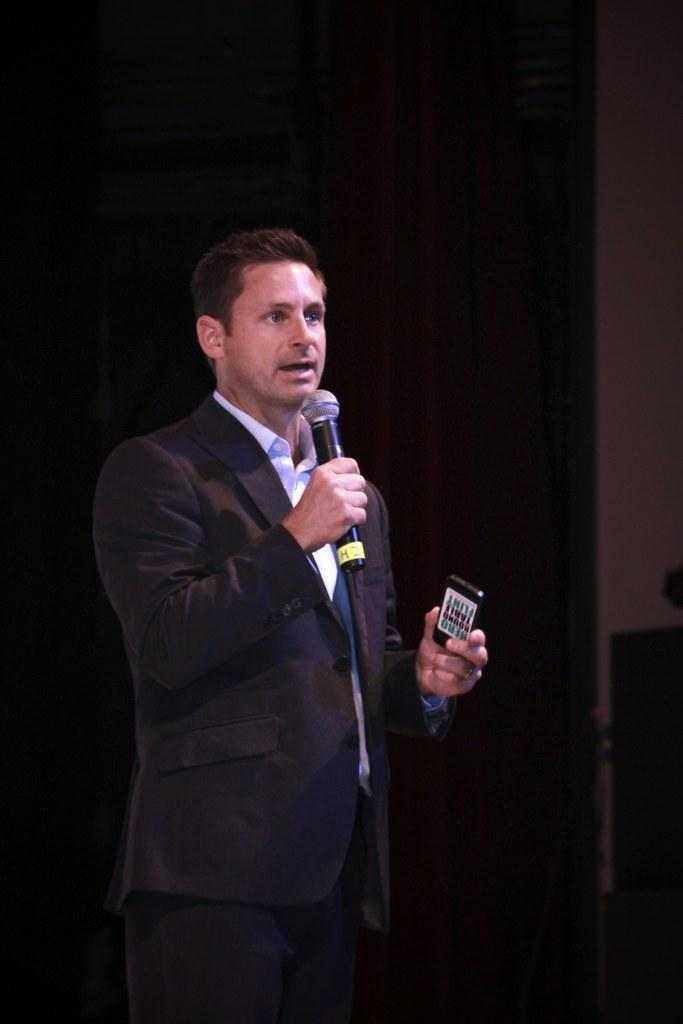What is the main subject of the image? The main subject of the image is a man. What is the man wearing? The man is wearing a blazer. What is the man holding in one hand? The man is holding a microphone in one hand. What is the man doing in the image? The man is talking. What is the man holding in the other hand? The man is holding a remote in the other hand. What can be seen in the background of the image? There is a wall in the background of the image. How would you describe the lighting in the image? The background of the image is dark. Can you see a snake slithering on the wall in the image? There is no snake present in the image; it only features a man holding a microphone and a remote, with a dark background and a wall. 